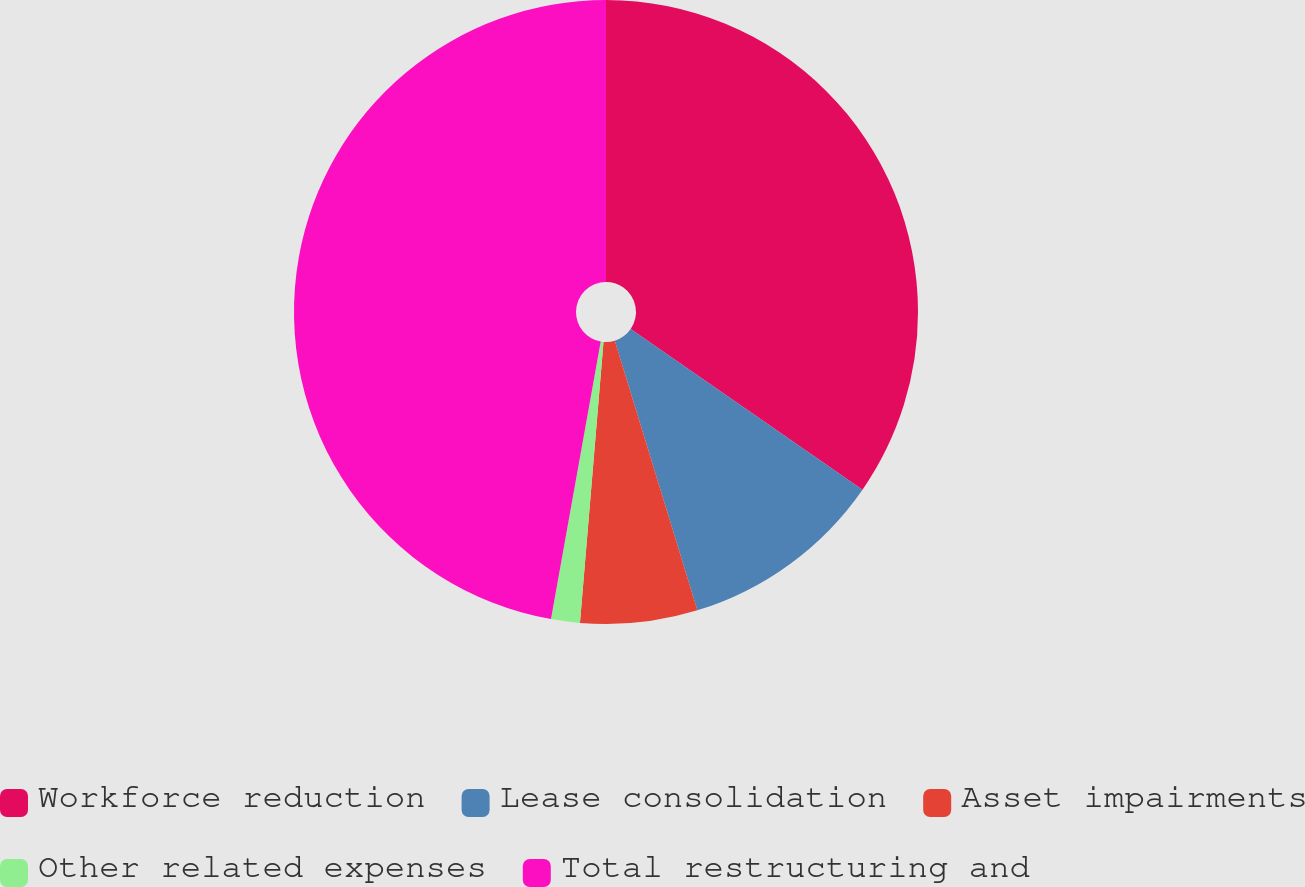Convert chart. <chart><loc_0><loc_0><loc_500><loc_500><pie_chart><fcel>Workforce reduction<fcel>Lease consolidation<fcel>Asset impairments<fcel>Other related expenses<fcel>Total restructuring and<nl><fcel>34.64%<fcel>10.63%<fcel>6.06%<fcel>1.49%<fcel>47.18%<nl></chart> 